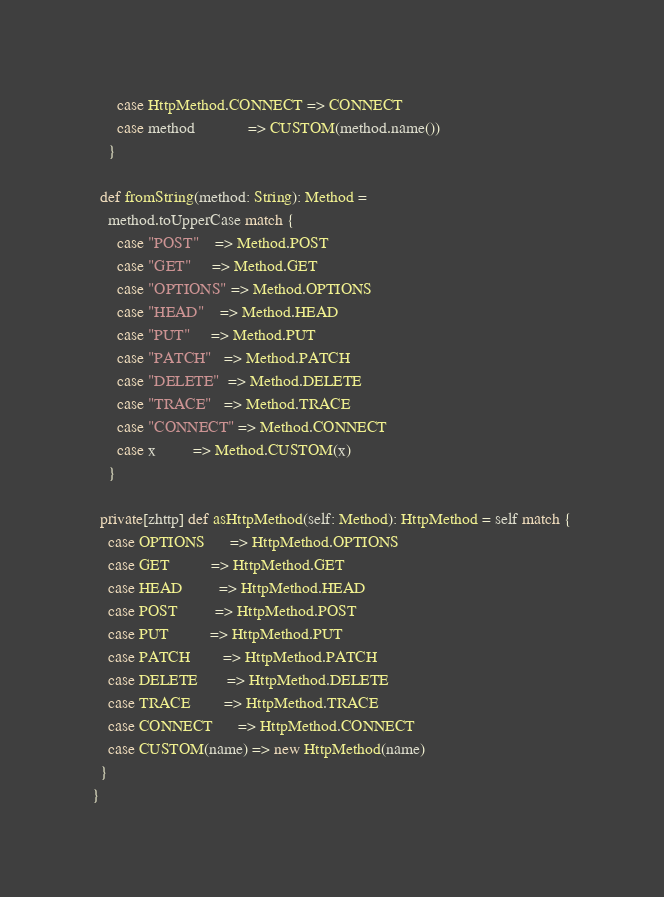<code> <loc_0><loc_0><loc_500><loc_500><_Scala_>      case HttpMethod.CONNECT => CONNECT
      case method             => CUSTOM(method.name())
    }

  def fromString(method: String): Method =
    method.toUpperCase match {
      case "POST"    => Method.POST
      case "GET"     => Method.GET
      case "OPTIONS" => Method.OPTIONS
      case "HEAD"    => Method.HEAD
      case "PUT"     => Method.PUT
      case "PATCH"   => Method.PATCH
      case "DELETE"  => Method.DELETE
      case "TRACE"   => Method.TRACE
      case "CONNECT" => Method.CONNECT
      case x         => Method.CUSTOM(x)
    }

  private[zhttp] def asHttpMethod(self: Method): HttpMethod = self match {
    case OPTIONS      => HttpMethod.OPTIONS
    case GET          => HttpMethod.GET
    case HEAD         => HttpMethod.HEAD
    case POST         => HttpMethod.POST
    case PUT          => HttpMethod.PUT
    case PATCH        => HttpMethod.PATCH
    case DELETE       => HttpMethod.DELETE
    case TRACE        => HttpMethod.TRACE
    case CONNECT      => HttpMethod.CONNECT
    case CUSTOM(name) => new HttpMethod(name)
  }
}
</code> 